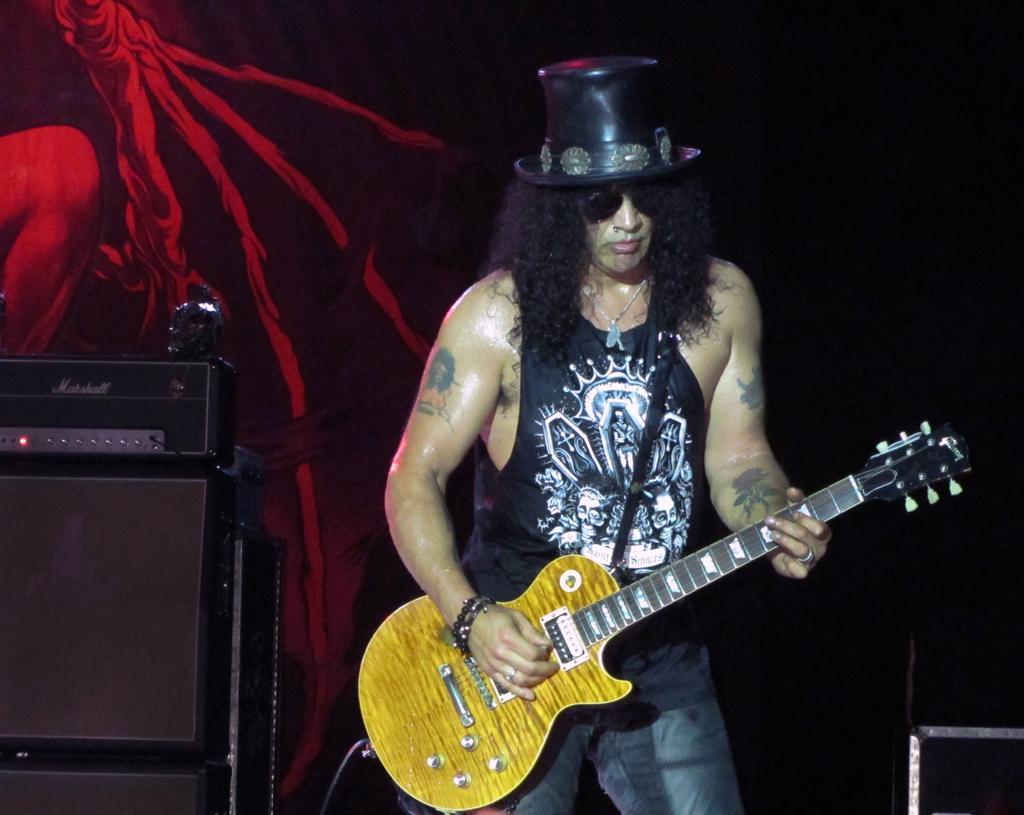Could you give a brief overview of what you see in this image? There is a man holding a guitar on the stage. He is wearing a black t shirt and hat on his head, also wearing spectacles. In the background there is a wall painted on it. 